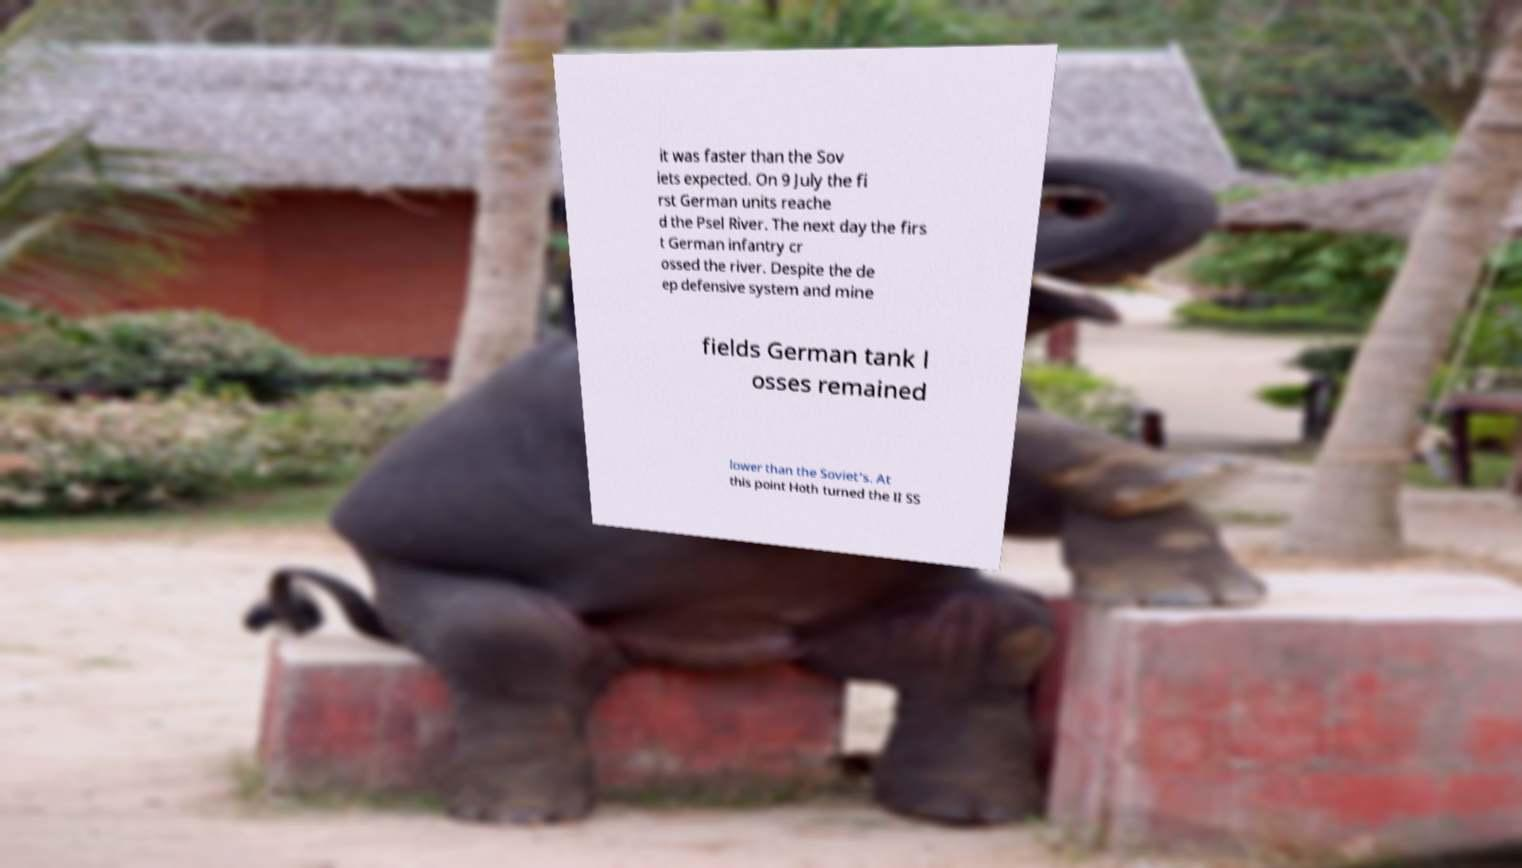I need the written content from this picture converted into text. Can you do that? it was faster than the Sov iets expected. On 9 July the fi rst German units reache d the Psel River. The next day the firs t German infantry cr ossed the river. Despite the de ep defensive system and mine fields German tank l osses remained lower than the Soviet's. At this point Hoth turned the II SS 